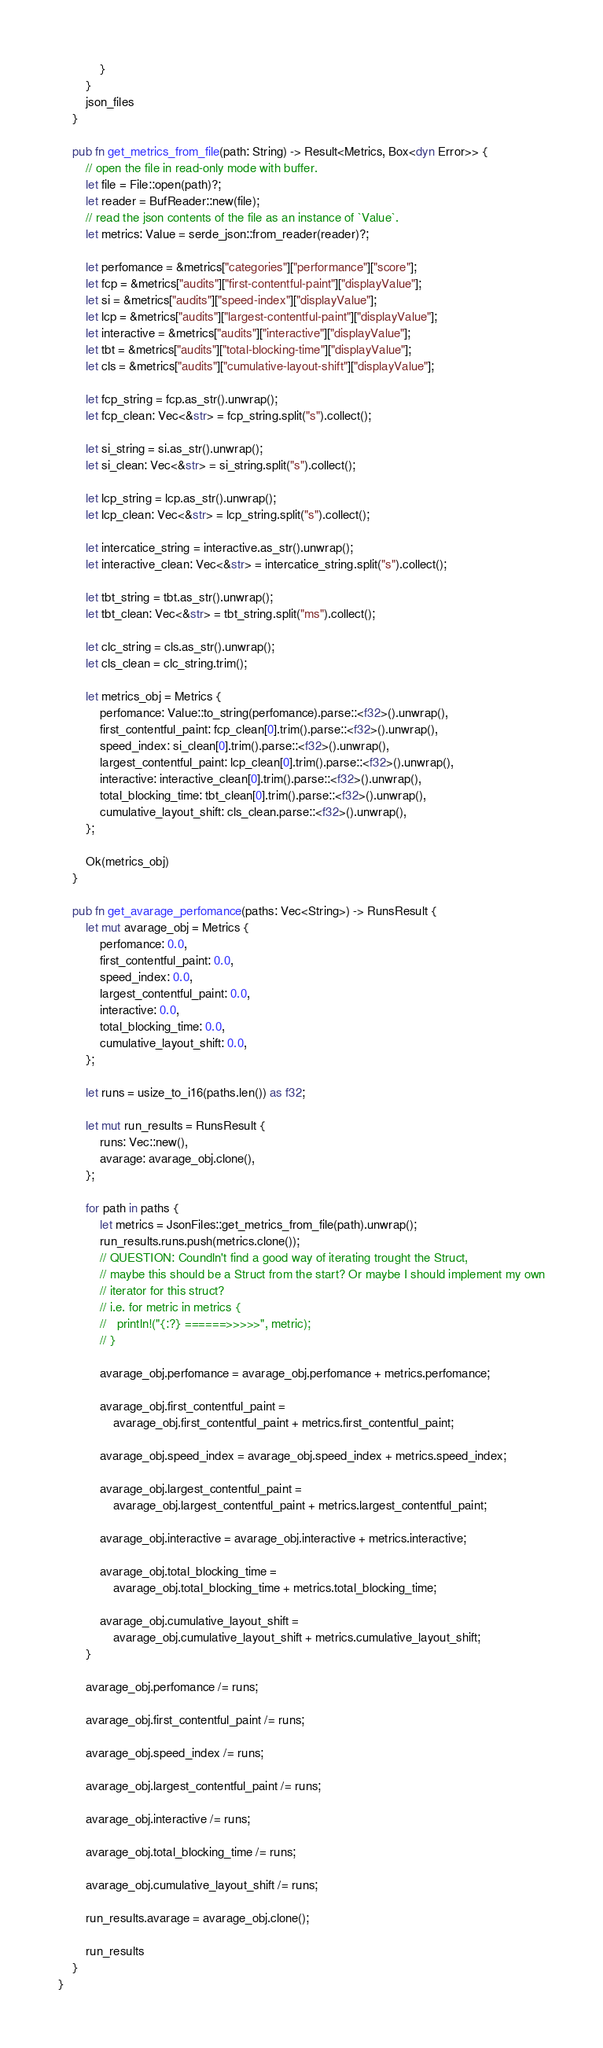Convert code to text. <code><loc_0><loc_0><loc_500><loc_500><_Rust_>            }
        }
        json_files
    }

    pub fn get_metrics_from_file(path: String) -> Result<Metrics, Box<dyn Error>> {
        // open the file in read-only mode with buffer.
        let file = File::open(path)?;
        let reader = BufReader::new(file);
        // read the json contents of the file as an instance of `Value`.
        let metrics: Value = serde_json::from_reader(reader)?;

        let perfomance = &metrics["categories"]["performance"]["score"];
        let fcp = &metrics["audits"]["first-contentful-paint"]["displayValue"];
        let si = &metrics["audits"]["speed-index"]["displayValue"];
        let lcp = &metrics["audits"]["largest-contentful-paint"]["displayValue"];
        let interactive = &metrics["audits"]["interactive"]["displayValue"];
        let tbt = &metrics["audits"]["total-blocking-time"]["displayValue"];
        let cls = &metrics["audits"]["cumulative-layout-shift"]["displayValue"];

        let fcp_string = fcp.as_str().unwrap();
        let fcp_clean: Vec<&str> = fcp_string.split("s").collect();

        let si_string = si.as_str().unwrap();
        let si_clean: Vec<&str> = si_string.split("s").collect();

        let lcp_string = lcp.as_str().unwrap();
        let lcp_clean: Vec<&str> = lcp_string.split("s").collect();

        let intercatice_string = interactive.as_str().unwrap();
        let interactive_clean: Vec<&str> = intercatice_string.split("s").collect();

        let tbt_string = tbt.as_str().unwrap();
        let tbt_clean: Vec<&str> = tbt_string.split("ms").collect();

        let clc_string = cls.as_str().unwrap();
        let cls_clean = clc_string.trim();

        let metrics_obj = Metrics {
            perfomance: Value::to_string(perfomance).parse::<f32>().unwrap(),
            first_contentful_paint: fcp_clean[0].trim().parse::<f32>().unwrap(),
            speed_index: si_clean[0].trim().parse::<f32>().unwrap(),
            largest_contentful_paint: lcp_clean[0].trim().parse::<f32>().unwrap(),
            interactive: interactive_clean[0].trim().parse::<f32>().unwrap(),
            total_blocking_time: tbt_clean[0].trim().parse::<f32>().unwrap(),
            cumulative_layout_shift: cls_clean.parse::<f32>().unwrap(),
        };

        Ok(metrics_obj)
    }

    pub fn get_avarage_perfomance(paths: Vec<String>) -> RunsResult {
        let mut avarage_obj = Metrics {
            perfomance: 0.0,
            first_contentful_paint: 0.0,
            speed_index: 0.0,
            largest_contentful_paint: 0.0,
            interactive: 0.0,
            total_blocking_time: 0.0,
            cumulative_layout_shift: 0.0,
        };

        let runs = usize_to_i16(paths.len()) as f32;

        let mut run_results = RunsResult {
            runs: Vec::new(),
            avarage: avarage_obj.clone(),
        };

        for path in paths {
            let metrics = JsonFiles::get_metrics_from_file(path).unwrap();
            run_results.runs.push(metrics.clone());
            // QUESTION: Coundln't find a good way of iterating trought the Struct,
            // maybe this should be a Struct from the start? Or maybe I should implement my own
            // iterator for this struct?
            // i.e. for metric in metrics {
            //   println!("{:?} ======>>>>>", metric);
            // }

            avarage_obj.perfomance = avarage_obj.perfomance + metrics.perfomance;

            avarage_obj.first_contentful_paint =
                avarage_obj.first_contentful_paint + metrics.first_contentful_paint;

            avarage_obj.speed_index = avarage_obj.speed_index + metrics.speed_index;

            avarage_obj.largest_contentful_paint =
                avarage_obj.largest_contentful_paint + metrics.largest_contentful_paint;

            avarage_obj.interactive = avarage_obj.interactive + metrics.interactive;

            avarage_obj.total_blocking_time =
                avarage_obj.total_blocking_time + metrics.total_blocking_time;

            avarage_obj.cumulative_layout_shift =
                avarage_obj.cumulative_layout_shift + metrics.cumulative_layout_shift;
        }

        avarage_obj.perfomance /= runs;

        avarage_obj.first_contentful_paint /= runs;

        avarage_obj.speed_index /= runs;

        avarage_obj.largest_contentful_paint /= runs;

        avarage_obj.interactive /= runs;

        avarage_obj.total_blocking_time /= runs;

        avarage_obj.cumulative_layout_shift /= runs;

        run_results.avarage = avarage_obj.clone();

        run_results
    }
}
</code> 